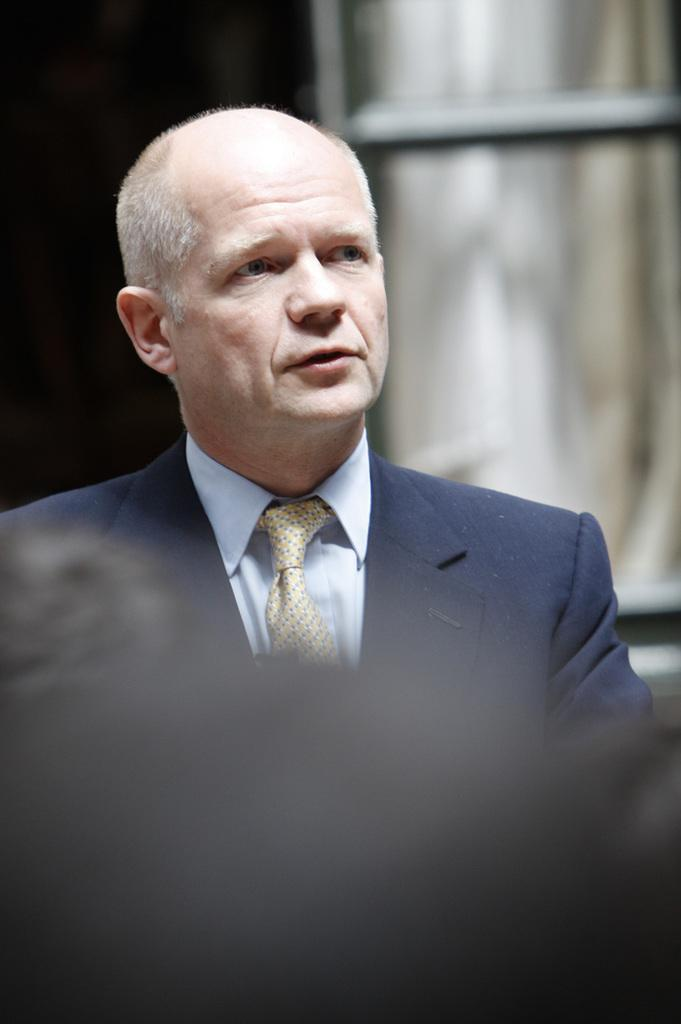Who is the main subject in the image? There is a man in the center of the image. What type of jam is being served in the lunchroom in the image? There is no mention of jam or a lunchroom in the image, so we cannot answer this question. 